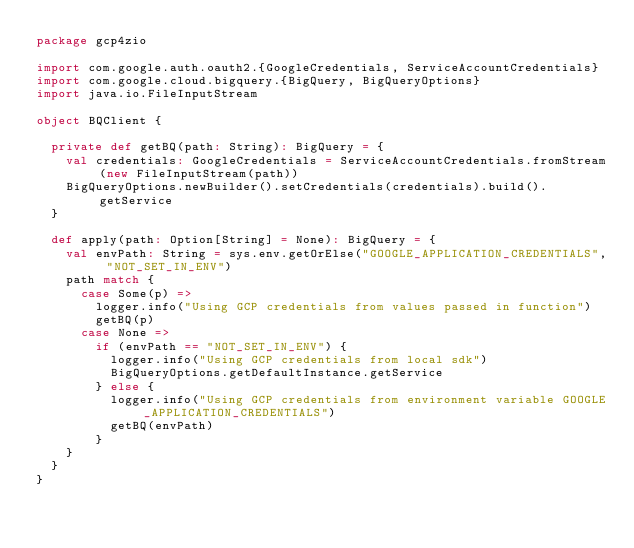Convert code to text. <code><loc_0><loc_0><loc_500><loc_500><_Scala_>package gcp4zio

import com.google.auth.oauth2.{GoogleCredentials, ServiceAccountCredentials}
import com.google.cloud.bigquery.{BigQuery, BigQueryOptions}
import java.io.FileInputStream

object BQClient {

  private def getBQ(path: String): BigQuery = {
    val credentials: GoogleCredentials = ServiceAccountCredentials.fromStream(new FileInputStream(path))
    BigQueryOptions.newBuilder().setCredentials(credentials).build().getService
  }

  def apply(path: Option[String] = None): BigQuery = {
    val envPath: String = sys.env.getOrElse("GOOGLE_APPLICATION_CREDENTIALS", "NOT_SET_IN_ENV")
    path match {
      case Some(p) =>
        logger.info("Using GCP credentials from values passed in function")
        getBQ(p)
      case None =>
        if (envPath == "NOT_SET_IN_ENV") {
          logger.info("Using GCP credentials from local sdk")
          BigQueryOptions.getDefaultInstance.getService
        } else {
          logger.info("Using GCP credentials from environment variable GOOGLE_APPLICATION_CREDENTIALS")
          getBQ(envPath)
        }
    }
  }
}
</code> 